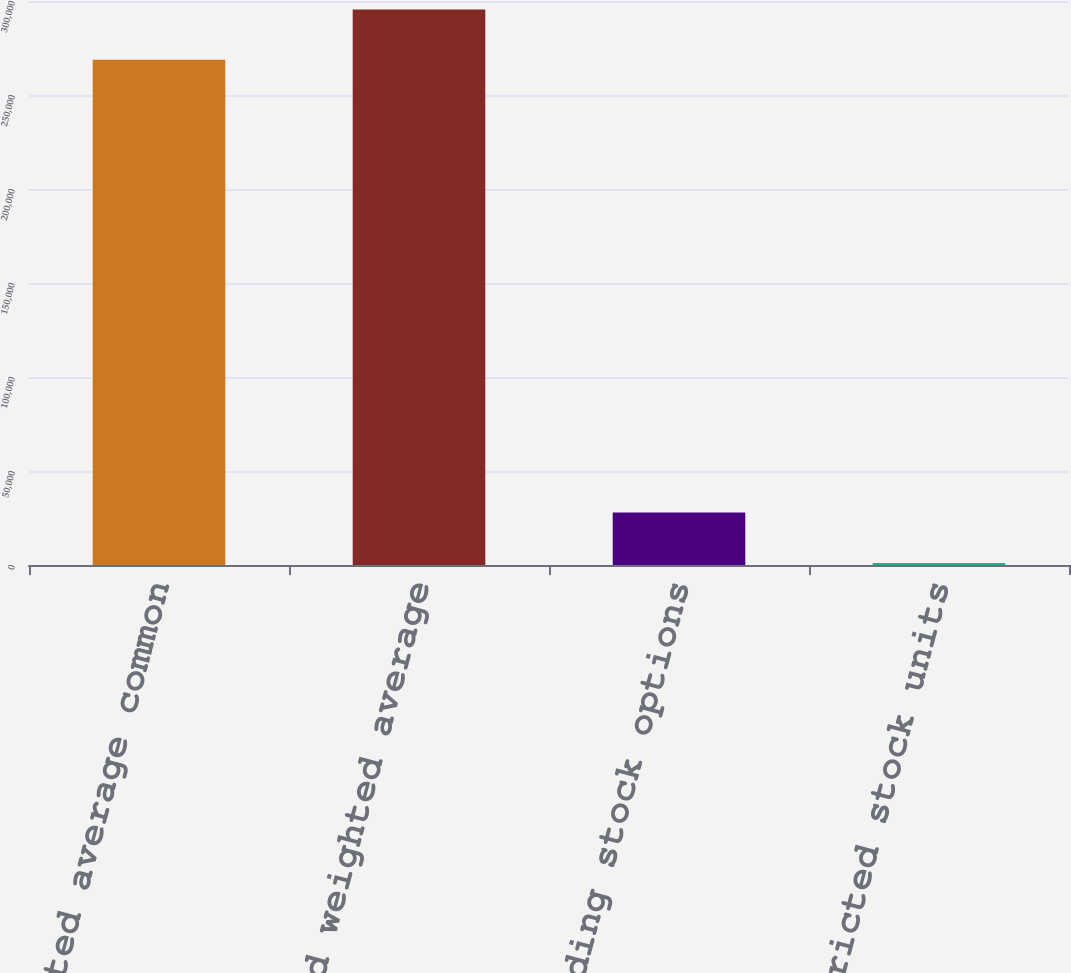<chart> <loc_0><loc_0><loc_500><loc_500><bar_chart><fcel>Basic weighted average common<fcel>Diluted weighted average<fcel>Outstanding stock options<fcel>Restricted stock units<nl><fcel>268704<fcel>295464<fcel>27868.5<fcel>1109<nl></chart> 